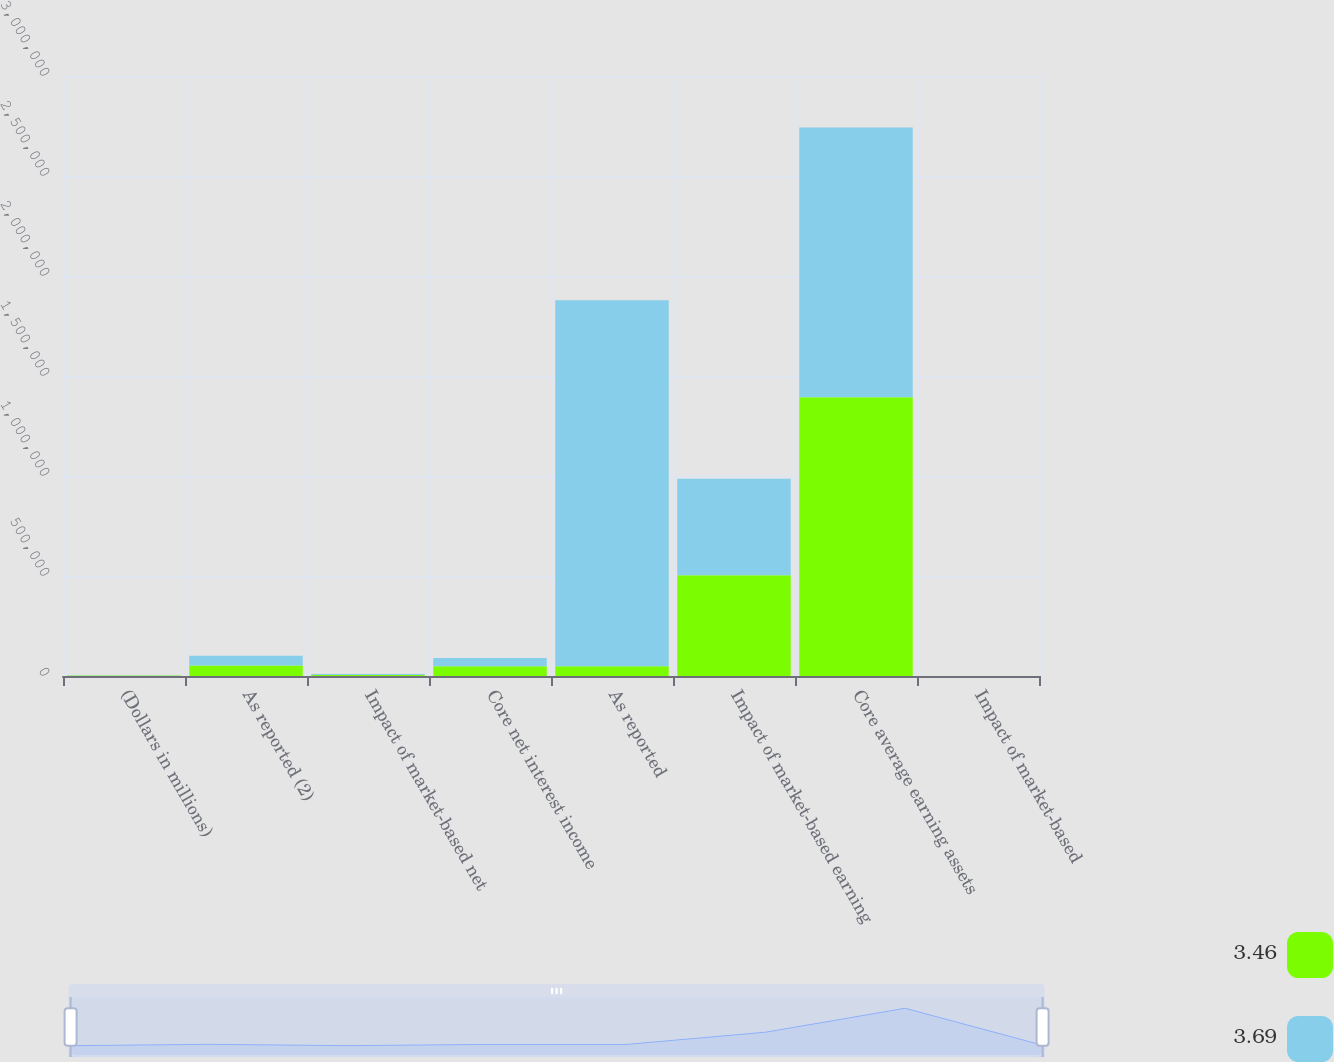Convert chart. <chart><loc_0><loc_0><loc_500><loc_500><stacked_bar_chart><ecel><fcel>(Dollars in millions)<fcel>As reported (2)<fcel>Impact of market-based net<fcel>Core net interest income<fcel>As reported<fcel>Impact of market-based earning<fcel>Core average earning assets<fcel>Impact of market-based<nl><fcel>3.46<fcel>2010<fcel>52693<fcel>4430<fcel>48263<fcel>48263<fcel>504360<fcel>1.39321e+06<fcel>0.68<nl><fcel>3.69<fcel>2009<fcel>48410<fcel>6117<fcel>42293<fcel>1.83019e+06<fcel>481376<fcel>1.34882e+06<fcel>0.49<nl></chart> 